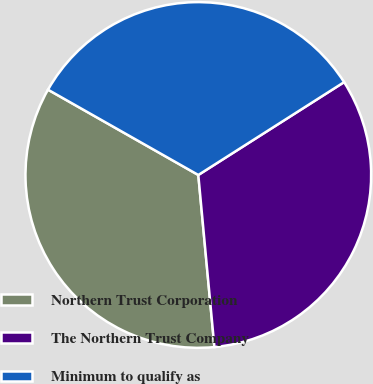Convert chart. <chart><loc_0><loc_0><loc_500><loc_500><pie_chart><fcel>Northern Trust Corporation<fcel>The Northern Trust Company<fcel>Minimum to qualify as<nl><fcel>34.7%<fcel>32.54%<fcel>32.76%<nl></chart> 